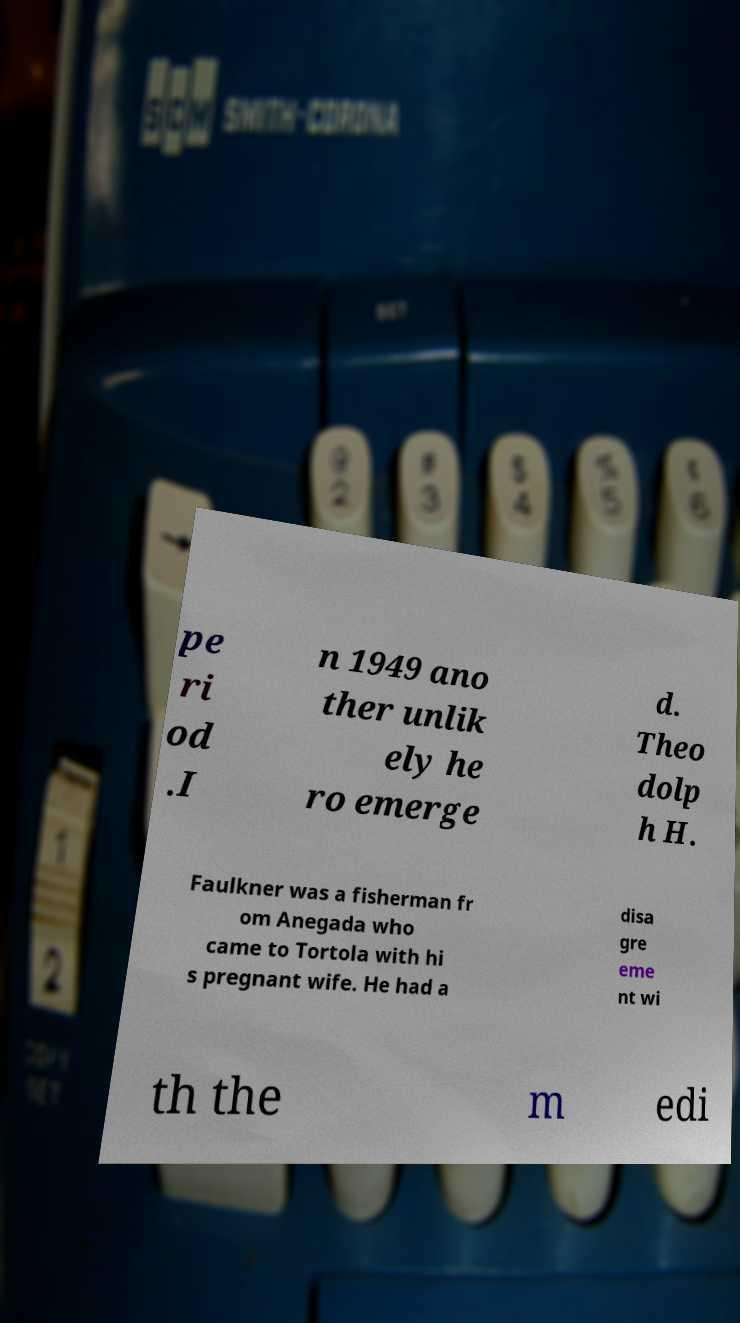Can you read and provide the text displayed in the image?This photo seems to have some interesting text. Can you extract and type it out for me? pe ri od .I n 1949 ano ther unlik ely he ro emerge d. Theo dolp h H. Faulkner was a fisherman fr om Anegada who came to Tortola with hi s pregnant wife. He had a disa gre eme nt wi th the m edi 